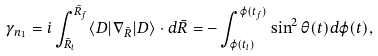<formula> <loc_0><loc_0><loc_500><loc_500>\gamma _ { n _ { 1 } } = i \int _ { \bar { R } _ { i } } ^ { \bar { R } _ { f } } \langle D | \nabla _ { \bar { R } } | D \rangle \cdot d \bar { R } = - \int _ { \varphi ( t _ { i } ) } ^ { \varphi ( t _ { f } ) } \sin ^ { 2 } \theta ( t ) d \varphi ( t ) ,</formula> 